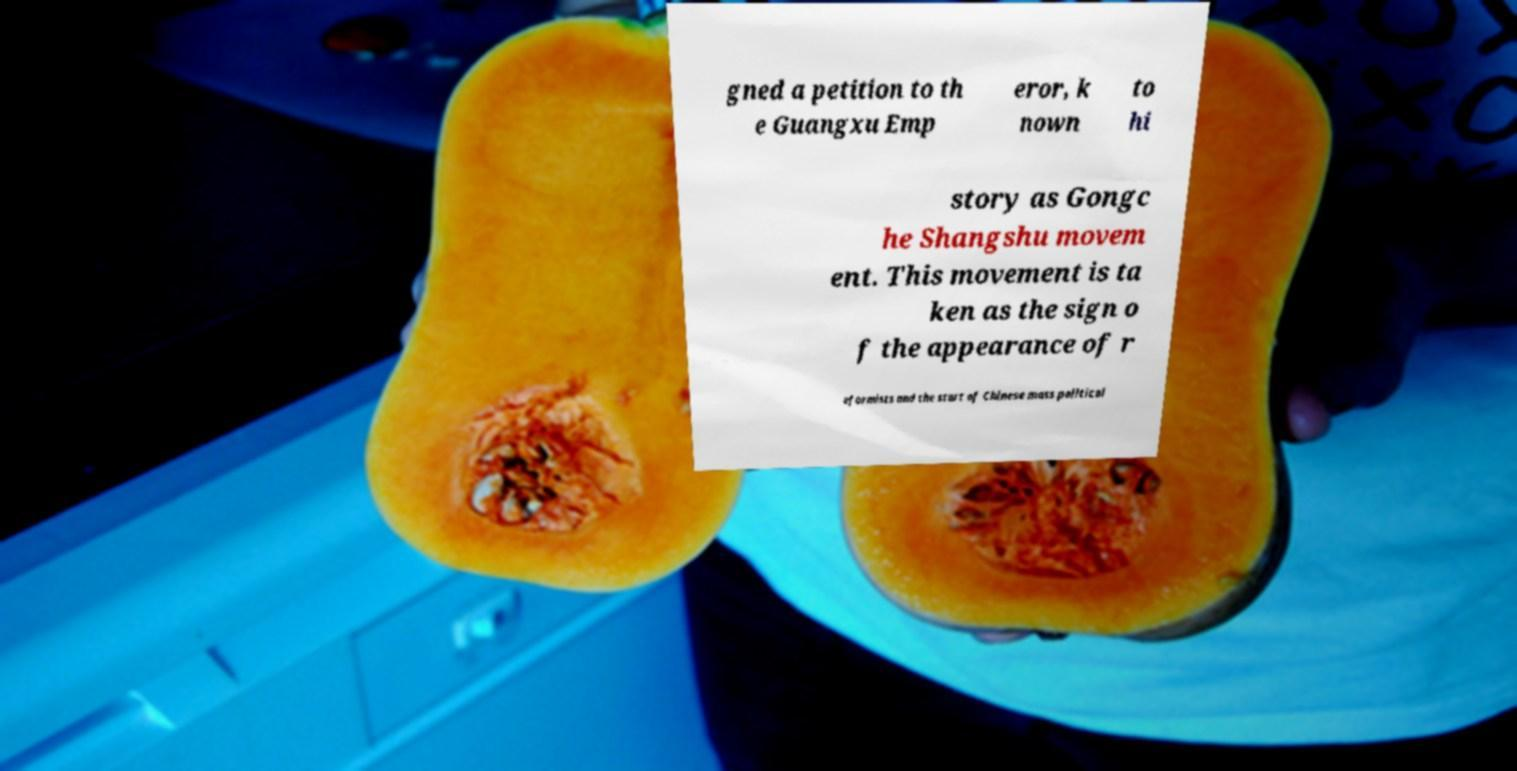Please identify and transcribe the text found in this image. gned a petition to th e Guangxu Emp eror, k nown to hi story as Gongc he Shangshu movem ent. This movement is ta ken as the sign o f the appearance of r eformists and the start of Chinese mass political 